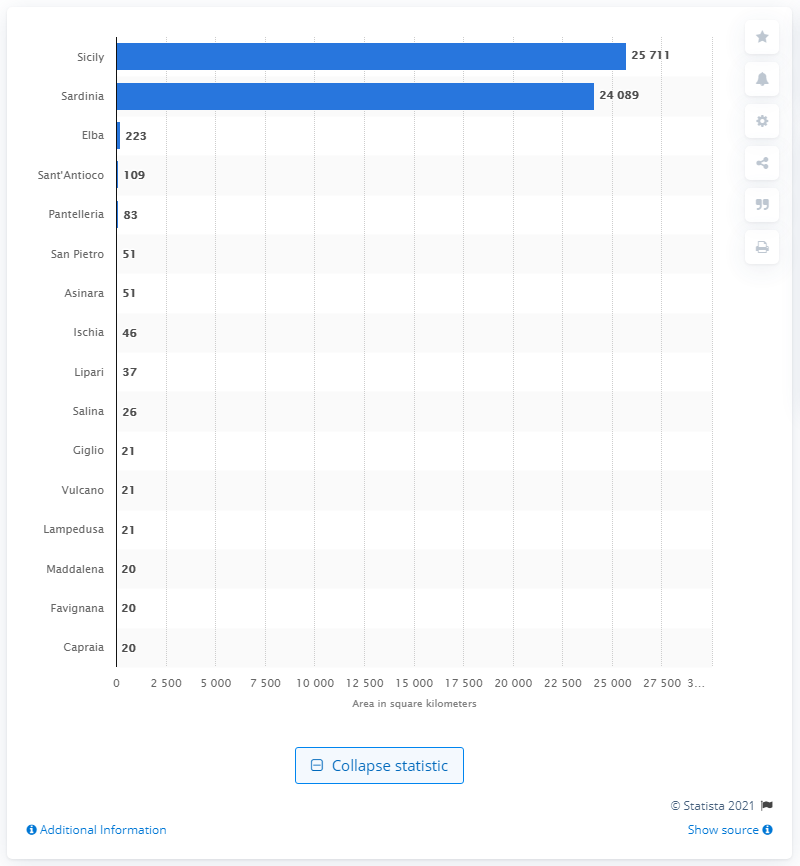Outline some significant characteristics in this image. Sicily is the largest island in Italy. 